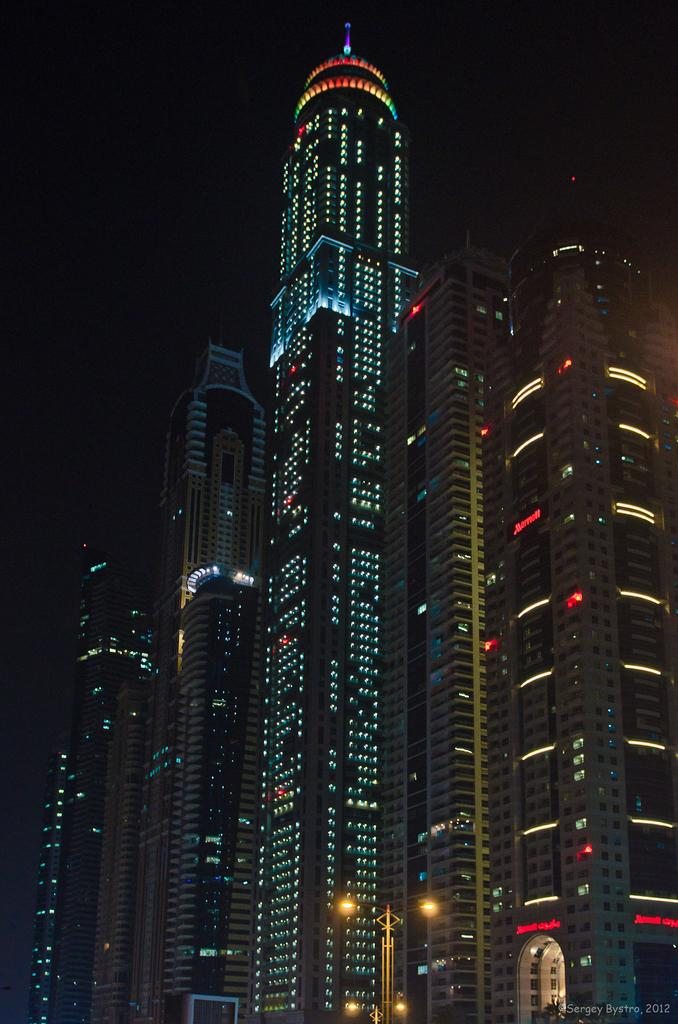What type of structures can be seen in the image? There are buildings in the image. What feature can be observed on the buildings? There are lights on the buildings. What type of illumination is present in the image? There are street lights visible in the image. What type of joke does the grandmother tell in the image? There is no grandmother or joke present in the image. 